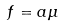Convert formula to latex. <formula><loc_0><loc_0><loc_500><loc_500>f = a \mu</formula> 